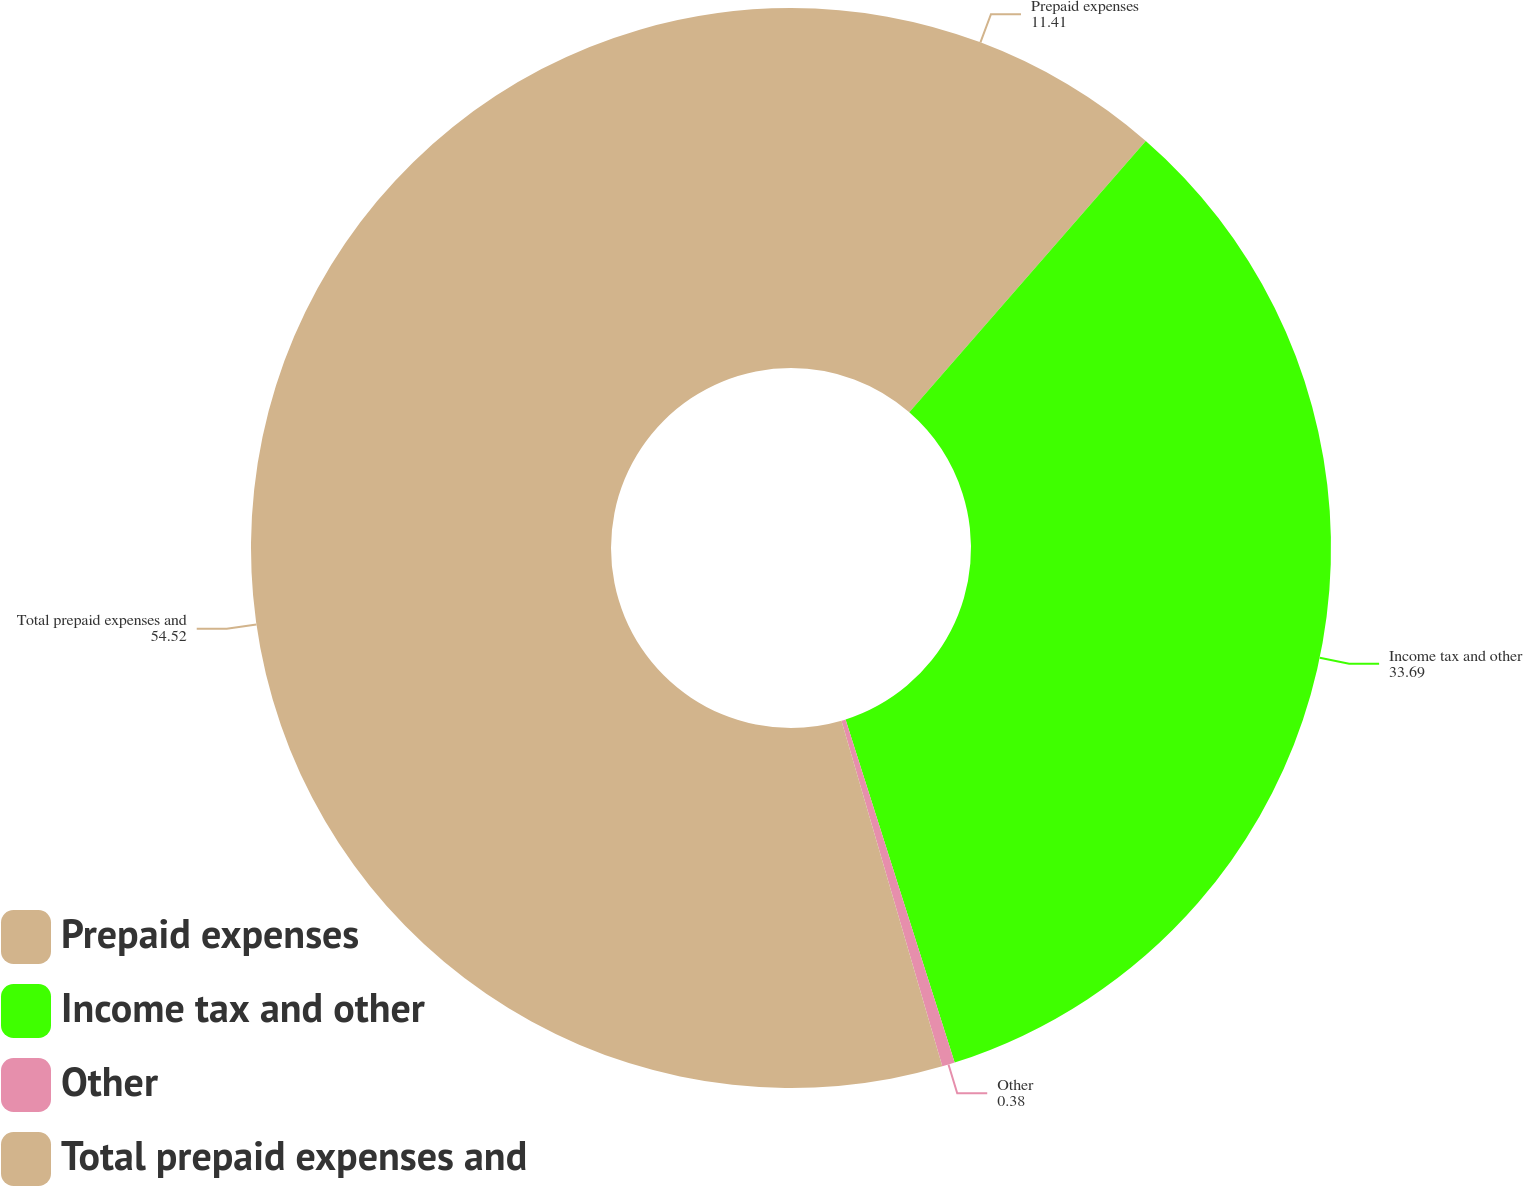Convert chart. <chart><loc_0><loc_0><loc_500><loc_500><pie_chart><fcel>Prepaid expenses<fcel>Income tax and other<fcel>Other<fcel>Total prepaid expenses and<nl><fcel>11.41%<fcel>33.69%<fcel>0.38%<fcel>54.52%<nl></chart> 